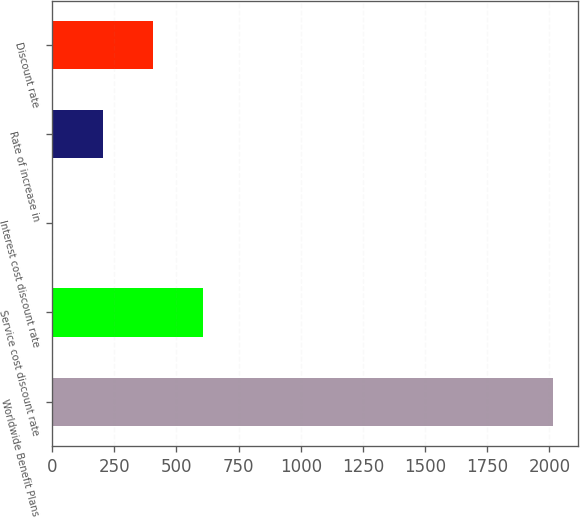Convert chart. <chart><loc_0><loc_0><loc_500><loc_500><bar_chart><fcel>Worldwide Benefit Plans<fcel>Service cost discount rate<fcel>Interest cost discount rate<fcel>Rate of increase in<fcel>Discount rate<nl><fcel>2016<fcel>607.67<fcel>4.1<fcel>205.29<fcel>406.48<nl></chart> 